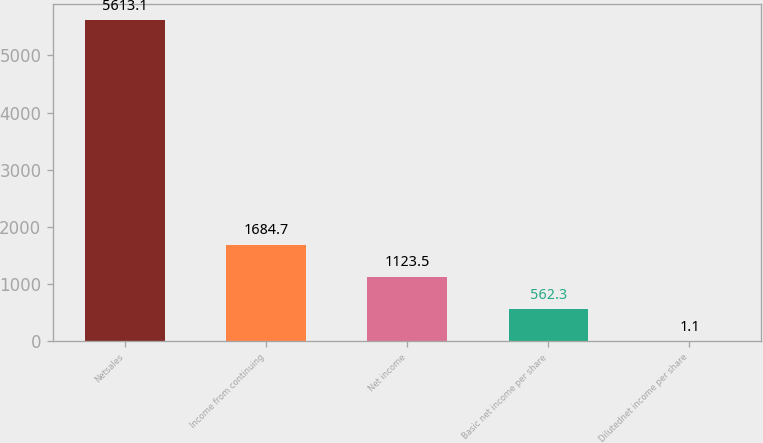Convert chart to OTSL. <chart><loc_0><loc_0><loc_500><loc_500><bar_chart><fcel>Netsales<fcel>Income from continuing<fcel>Net income<fcel>Basic net income per share<fcel>Dilutednet income per share<nl><fcel>5613.1<fcel>1684.7<fcel>1123.5<fcel>562.3<fcel>1.1<nl></chart> 